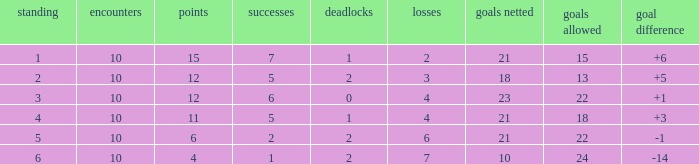Can you tell me the lowest Played that has the Position larger than 2, and the Draws smaller than 2, and the Goals against smaller than 18? None. 